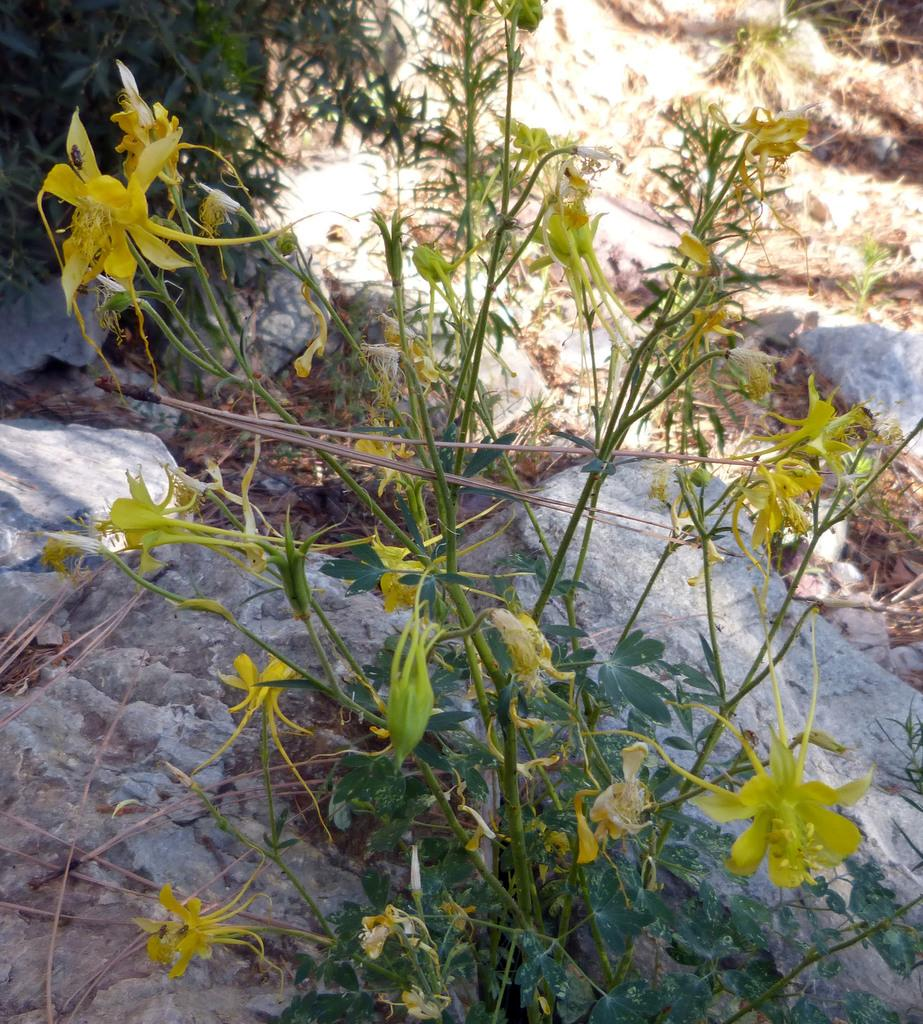What type of living organisms are present in the image? There are flowers in the image. To which plant do the flowers belong? The flowers belong to a plant. What can be seen in the background behind the plant? There are rocks visible behind the plant. How many boxes does the boy carry in the image? There is no boy or box present in the image; it features flowers and a plant with rocks in the background. 